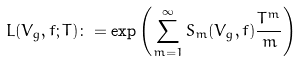Convert formula to latex. <formula><loc_0><loc_0><loc_500><loc_500>L ( V _ { g } , f ; T ) \colon = \exp \left ( \sum _ { m = 1 } ^ { \infty } S _ { m } ( V _ { g } , f ) \frac { T ^ { m } } { m } \right )</formula> 